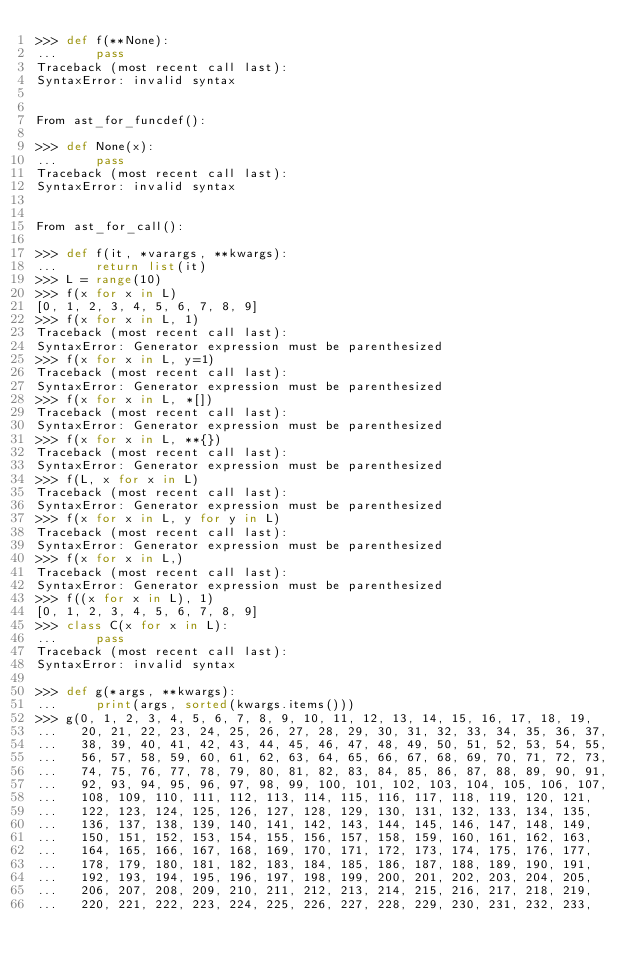<code> <loc_0><loc_0><loc_500><loc_500><_Python_>>>> def f(**None):
...     pass
Traceback (most recent call last):
SyntaxError: invalid syntax


From ast_for_funcdef():

>>> def None(x):
...     pass
Traceback (most recent call last):
SyntaxError: invalid syntax


From ast_for_call():

>>> def f(it, *varargs, **kwargs):
...     return list(it)
>>> L = range(10)
>>> f(x for x in L)
[0, 1, 2, 3, 4, 5, 6, 7, 8, 9]
>>> f(x for x in L, 1)
Traceback (most recent call last):
SyntaxError: Generator expression must be parenthesized
>>> f(x for x in L, y=1)
Traceback (most recent call last):
SyntaxError: Generator expression must be parenthesized
>>> f(x for x in L, *[])
Traceback (most recent call last):
SyntaxError: Generator expression must be parenthesized
>>> f(x for x in L, **{})
Traceback (most recent call last):
SyntaxError: Generator expression must be parenthesized
>>> f(L, x for x in L)
Traceback (most recent call last):
SyntaxError: Generator expression must be parenthesized
>>> f(x for x in L, y for y in L)
Traceback (most recent call last):
SyntaxError: Generator expression must be parenthesized
>>> f(x for x in L,)
Traceback (most recent call last):
SyntaxError: Generator expression must be parenthesized
>>> f((x for x in L), 1)
[0, 1, 2, 3, 4, 5, 6, 7, 8, 9]
>>> class C(x for x in L):
...     pass
Traceback (most recent call last):
SyntaxError: invalid syntax

>>> def g(*args, **kwargs):
...     print(args, sorted(kwargs.items()))
>>> g(0, 1, 2, 3, 4, 5, 6, 7, 8, 9, 10, 11, 12, 13, 14, 15, 16, 17, 18, 19,
...   20, 21, 22, 23, 24, 25, 26, 27, 28, 29, 30, 31, 32, 33, 34, 35, 36, 37,
...   38, 39, 40, 41, 42, 43, 44, 45, 46, 47, 48, 49, 50, 51, 52, 53, 54, 55,
...   56, 57, 58, 59, 60, 61, 62, 63, 64, 65, 66, 67, 68, 69, 70, 71, 72, 73,
...   74, 75, 76, 77, 78, 79, 80, 81, 82, 83, 84, 85, 86, 87, 88, 89, 90, 91,
...   92, 93, 94, 95, 96, 97, 98, 99, 100, 101, 102, 103, 104, 105, 106, 107,
...   108, 109, 110, 111, 112, 113, 114, 115, 116, 117, 118, 119, 120, 121,
...   122, 123, 124, 125, 126, 127, 128, 129, 130, 131, 132, 133, 134, 135,
...   136, 137, 138, 139, 140, 141, 142, 143, 144, 145, 146, 147, 148, 149,
...   150, 151, 152, 153, 154, 155, 156, 157, 158, 159, 160, 161, 162, 163,
...   164, 165, 166, 167, 168, 169, 170, 171, 172, 173, 174, 175, 176, 177,
...   178, 179, 180, 181, 182, 183, 184, 185, 186, 187, 188, 189, 190, 191,
...   192, 193, 194, 195, 196, 197, 198, 199, 200, 201, 202, 203, 204, 205,
...   206, 207, 208, 209, 210, 211, 212, 213, 214, 215, 216, 217, 218, 219,
...   220, 221, 222, 223, 224, 225, 226, 227, 228, 229, 230, 231, 232, 233,</code> 